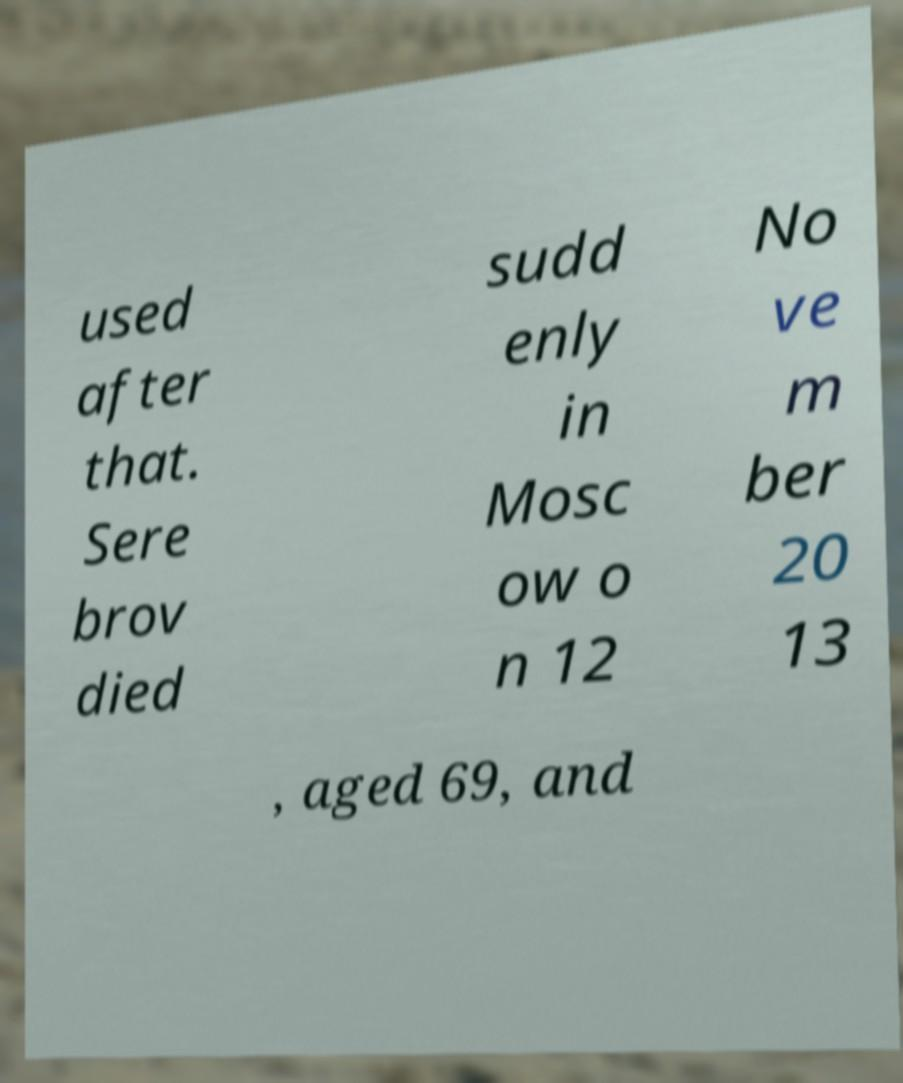What messages or text are displayed in this image? I need them in a readable, typed format. used after that. Sere brov died sudd enly in Mosc ow o n 12 No ve m ber 20 13 , aged 69, and 